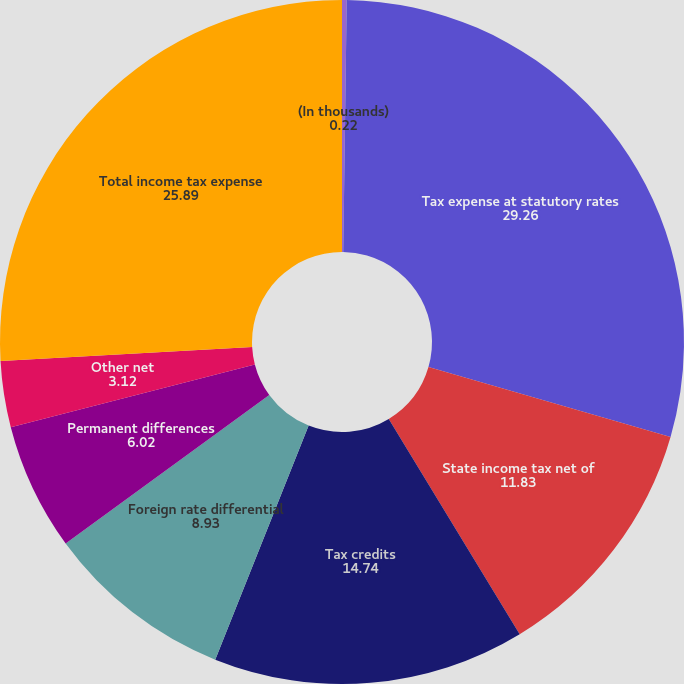<chart> <loc_0><loc_0><loc_500><loc_500><pie_chart><fcel>(In thousands)<fcel>Tax expense at statutory rates<fcel>State income tax net of<fcel>Tax credits<fcel>Foreign rate differential<fcel>Permanent differences<fcel>Other net<fcel>Total income tax expense<nl><fcel>0.22%<fcel>29.26%<fcel>11.83%<fcel>14.74%<fcel>8.93%<fcel>6.02%<fcel>3.12%<fcel>25.89%<nl></chart> 